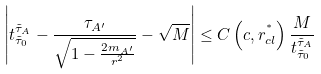Convert formula to latex. <formula><loc_0><loc_0><loc_500><loc_500>\left | t ^ { \tilde { \tau } _ { A } } _ { \tilde { \tau } _ { 0 } } - \frac { \tau _ { A ^ { \prime } } } { \sqrt { 1 - \frac { 2 m _ { A ^ { \prime } } } { r ^ { 2 } } } } - \sqrt { M } \right | \leq C \left ( c , r ^ { ^ { * } } _ { c l } \right ) \frac { M } { t ^ { \tilde { \tau } _ { A } } _ { \tilde { \tau } _ { 0 } } }</formula> 